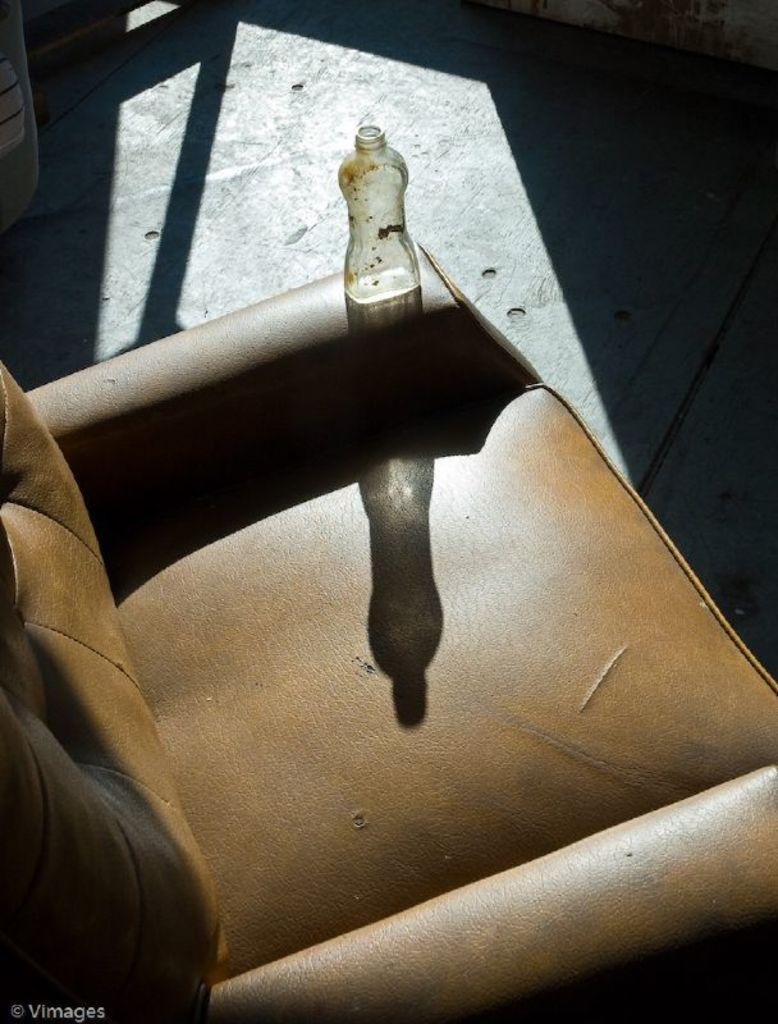What type of furniture is present in the image? There is a couch in the image. What object is placed on the couch? There is a glass bottle placed on the couch. What type of dolls can be seen in the hospital room in the image? There are no dolls or hospital rooms present in the image; it only features a couch and a glass bottle. 